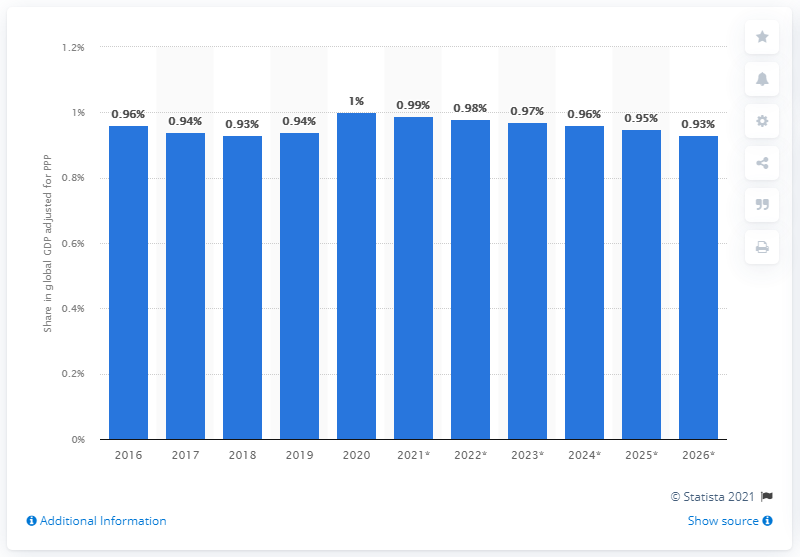Indicate a few pertinent items in this graphic. In 2020, Taiwan's share in the global gross domestic product adjusted for Purchasing Power Parity was approximately 1%. 